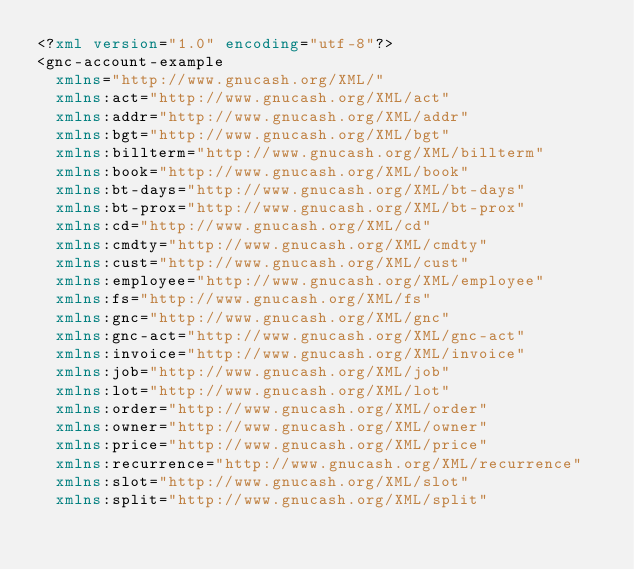Convert code to text. <code><loc_0><loc_0><loc_500><loc_500><_XML_><?xml version="1.0" encoding="utf-8"?>
<gnc-account-example
  xmlns="http://www.gnucash.org/XML/"
  xmlns:act="http://www.gnucash.org/XML/act"
  xmlns:addr="http://www.gnucash.org/XML/addr"
  xmlns:bgt="http://www.gnucash.org/XML/bgt"
  xmlns:billterm="http://www.gnucash.org/XML/billterm"
  xmlns:book="http://www.gnucash.org/XML/book"
  xmlns:bt-days="http://www.gnucash.org/XML/bt-days"
  xmlns:bt-prox="http://www.gnucash.org/XML/bt-prox"
  xmlns:cd="http://www.gnucash.org/XML/cd"
  xmlns:cmdty="http://www.gnucash.org/XML/cmdty"
  xmlns:cust="http://www.gnucash.org/XML/cust"
  xmlns:employee="http://www.gnucash.org/XML/employee"
  xmlns:fs="http://www.gnucash.org/XML/fs"
  xmlns:gnc="http://www.gnucash.org/XML/gnc"
  xmlns:gnc-act="http://www.gnucash.org/XML/gnc-act"
  xmlns:invoice="http://www.gnucash.org/XML/invoice"
  xmlns:job="http://www.gnucash.org/XML/job"
  xmlns:lot="http://www.gnucash.org/XML/lot"
  xmlns:order="http://www.gnucash.org/XML/order"
  xmlns:owner="http://www.gnucash.org/XML/owner"
  xmlns:price="http://www.gnucash.org/XML/price"
  xmlns:recurrence="http://www.gnucash.org/XML/recurrence"
  xmlns:slot="http://www.gnucash.org/XML/slot"
  xmlns:split="http://www.gnucash.org/XML/split"</code> 